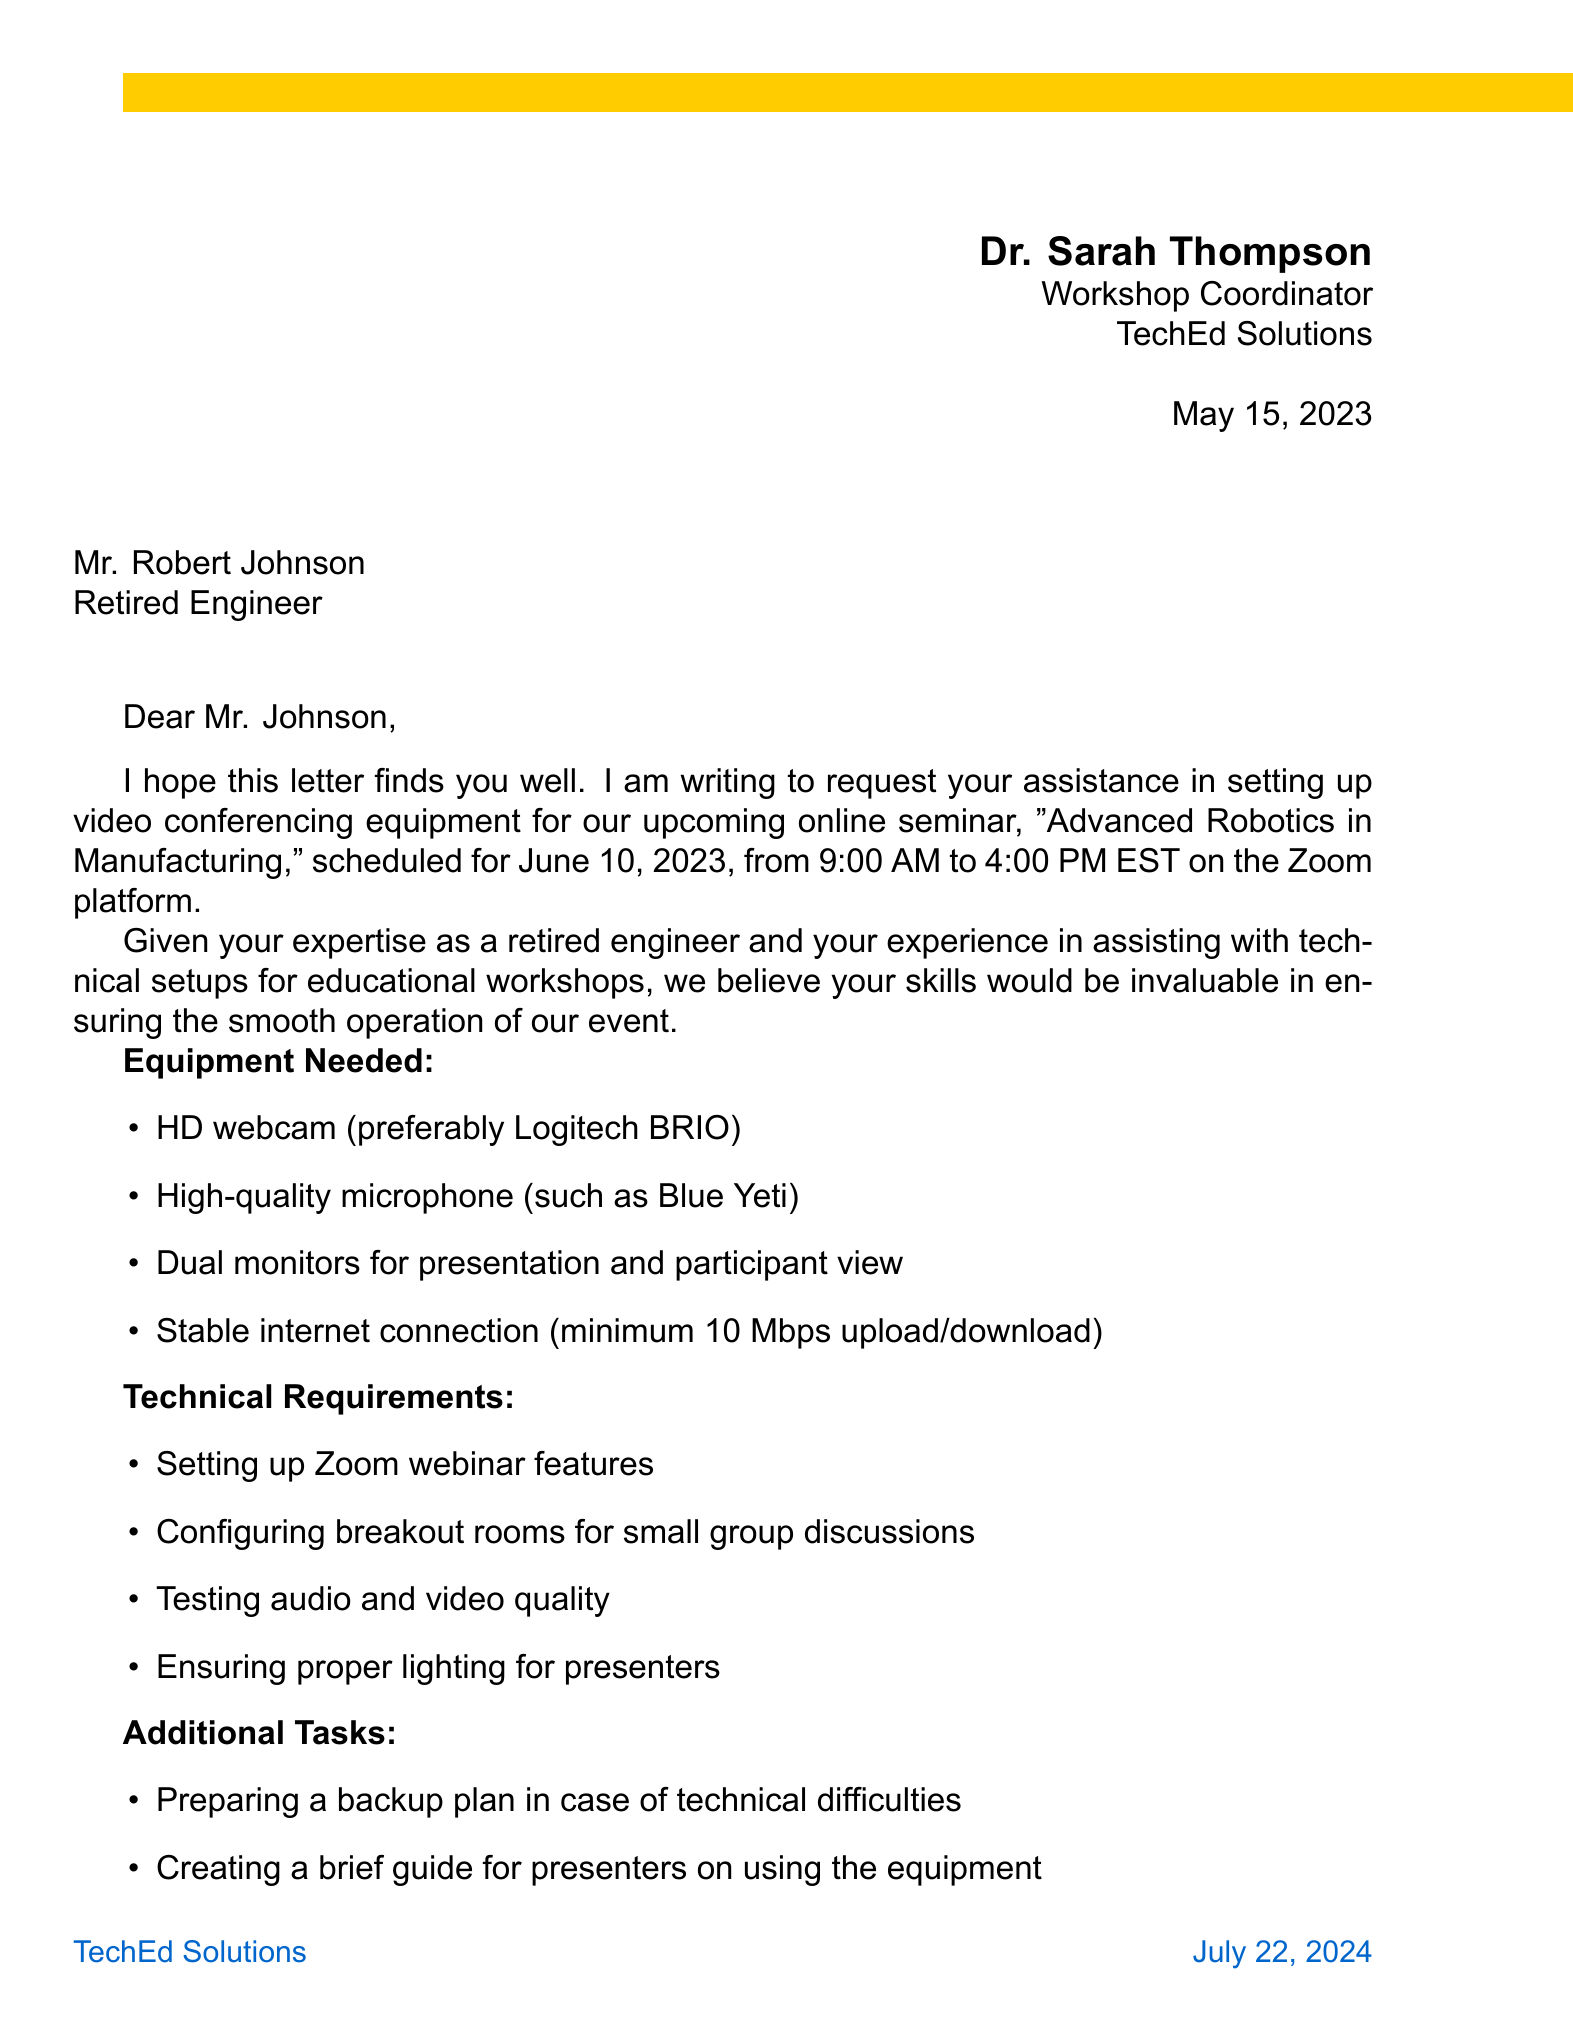What is the name of the workshop? The workshop title is mentioned in the letter as "Advanced Robotics in Manufacturing."
Answer: Advanced Robotics in Manufacturing Who is the sender of the letter? The sender's name and position are provided at the beginning of the letter.
Answer: Dr. Sarah Thompson What date is the seminar scheduled for? The date of the seminar is stated in the event details within the letter.
Answer: June 10, 2023 How much is the honorarium offered? The document specifies the amount offered for assistance as an honorarium.
Answer: $300 What platform will the seminar be held on? The platform for the seminar is indicated in the event details section of the letter.
Answer: Zoom What type of engineer is the recipient? The position of the recipient is mentioned in the greeting of the letter.
Answer: Retired Engineer What is one of the technical requirements listed? The letter includes a list of technical requirements that need to be met for the seminar.
Answer: Testing audio and video quality What is one of the additional tasks mentioned? The letter outlines additional tasks that the recipient is requested to perform.
Answer: Preparing a backup plan in case of technical difficulties What is the email address provided for contact? Contact information is given at the end of the letter, including an email address.
Answer: sarah.thompson@techedsolutions.com 